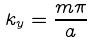Convert formula to latex. <formula><loc_0><loc_0><loc_500><loc_500>k _ { y } = \frac { m \pi } { a }</formula> 